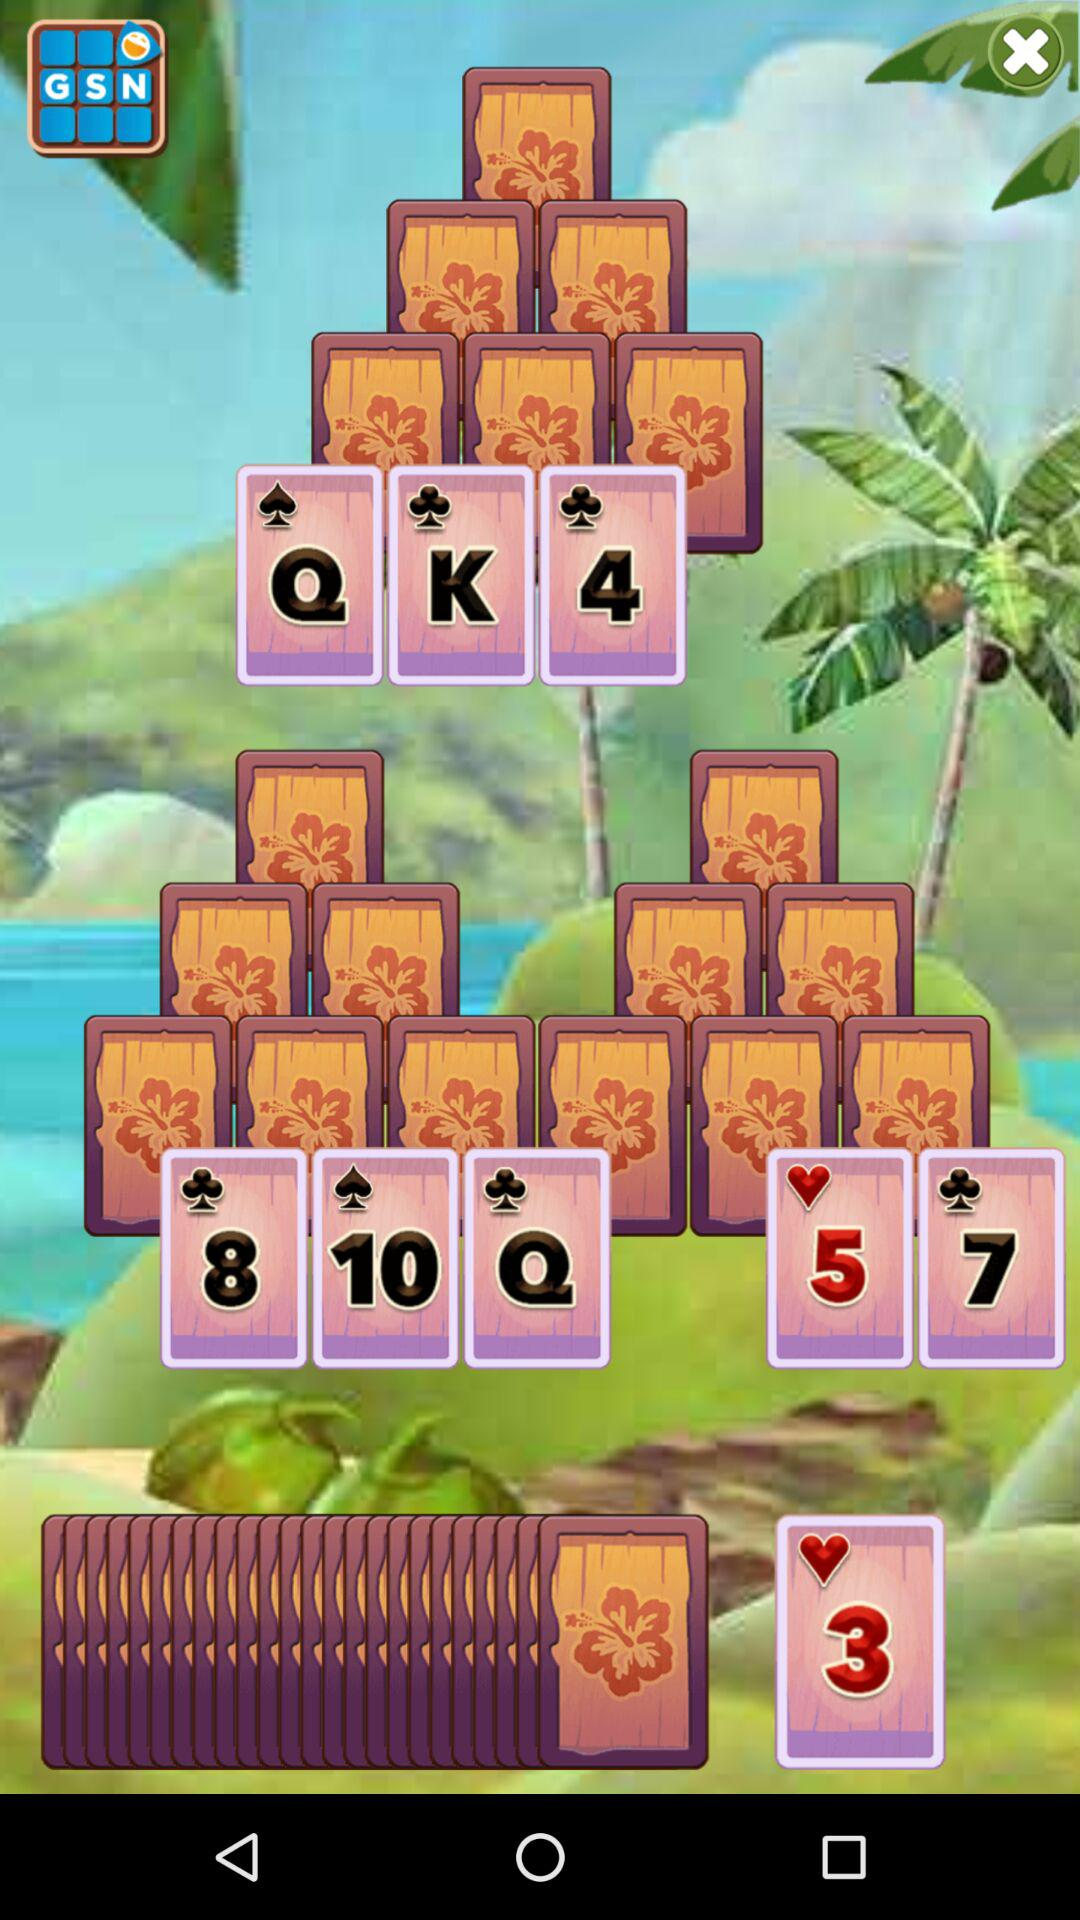How many cards have hearts on them?
Answer the question using a single word or phrase. 2 